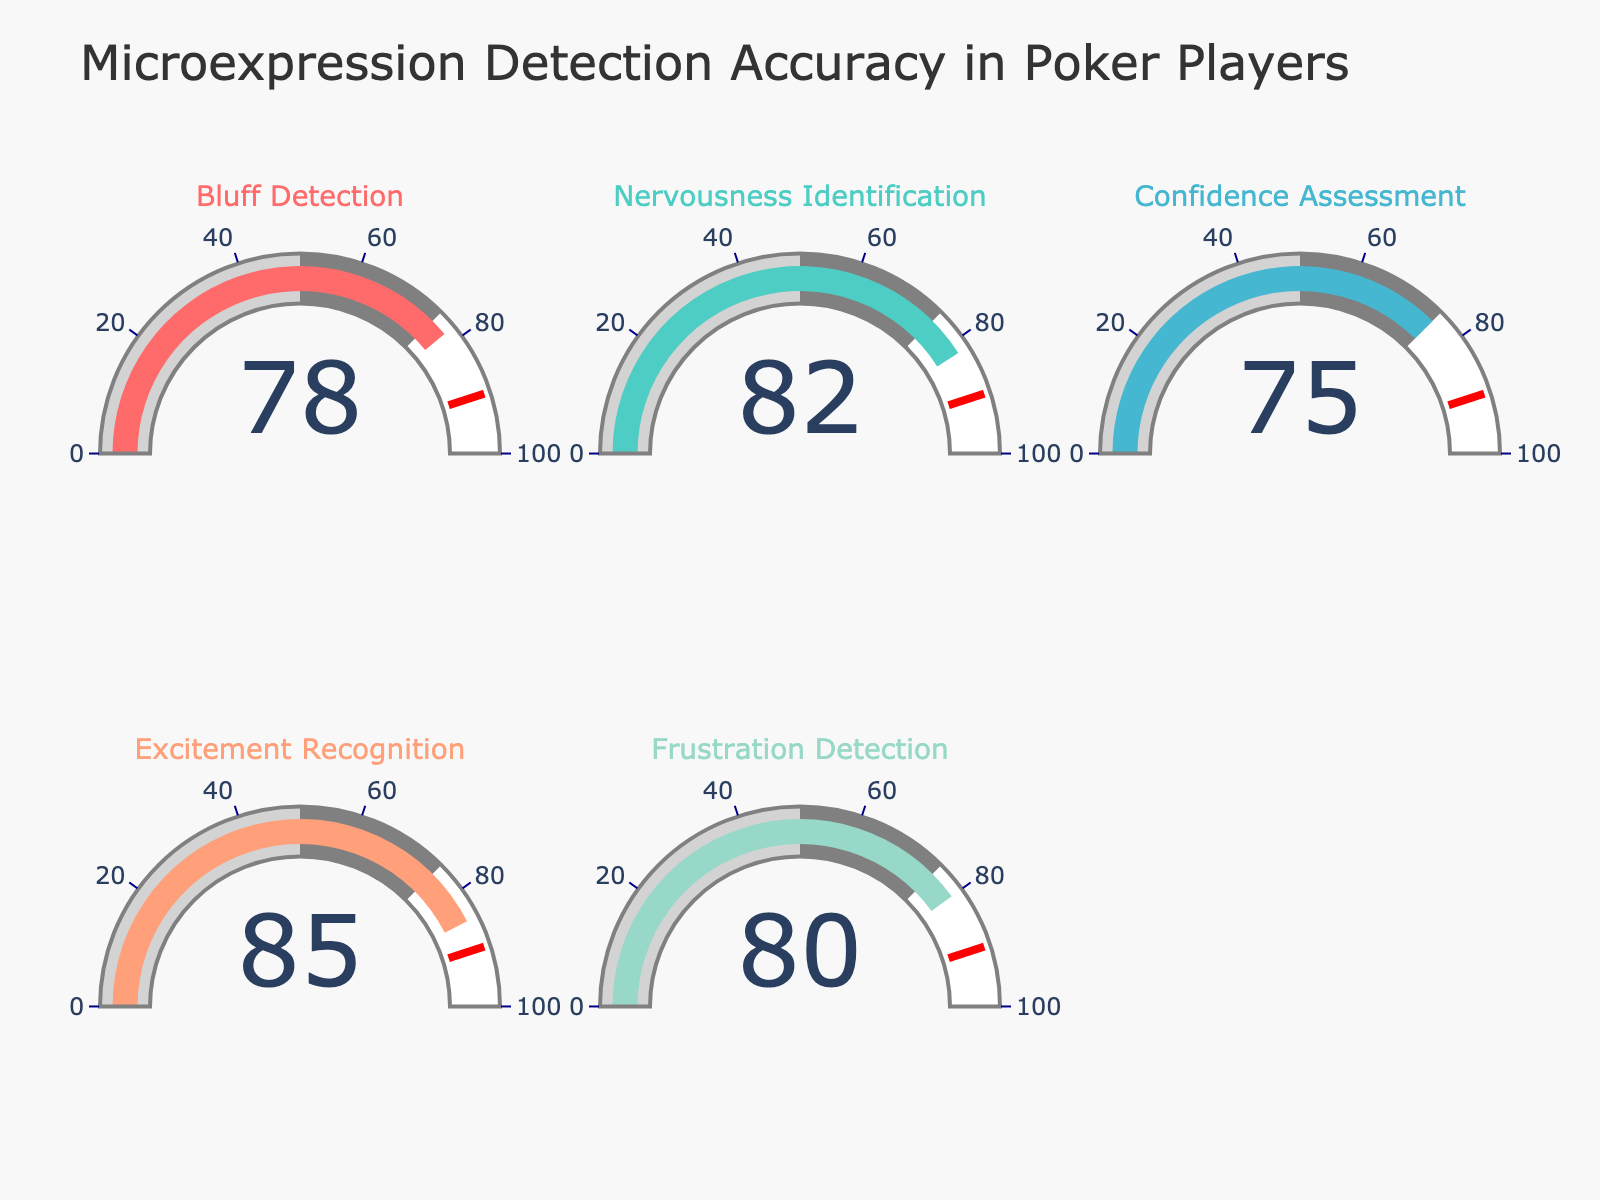What is the title of the figure? The title of the figure is displayed prominently at the top and reads "Microexpression Detection Accuracy in Poker Players".
Answer: Microexpression Detection Accuracy in Poker Players Which skill has the highest accuracy rate? The gauge chart visually shows the accuracy rates for various skills, and the highest value is displayed for "Excitement Recognition" at 85.
Answer: Excitement Recognition What is the range of numbers displayed on the gauges? Each gauge has an axis range that starts from 0 and ends at 100, as indicated by the tick marks on the gauge.
Answer: 0 to 100 What's the average accuracy rate across all skills? To find the average accuracy rate, sum all the individual accuracies and then divide by the number of skills. The sum is 78+82+75+85+80 = 400. There are 5 skills, so the average is 400/5 = 80.
Answer: 80 Which gauge color is used for "Nervousness Identification"? The gauge for "Nervousness Identification" has a light green color which helps distinguish it from the others.
Answer: Light green Is the accuracy rate for "Confidence Assessment" higher or lower than "Bluff Detection"? The gauge for "Confidence Assessment" shows an accuracy of 75, and the gauge for "Bluff Detection" shows 78, meaning the former is lower.
Answer: Lower What is the difference between the highest and lowest accuracy rates? The highest accuracy rate is 85 ("Excitement Recognition") and the lowest is 75 ("Confidence Assessment"). The difference is 85 - 75 = 10.
Answer: 10 What threshold value is indicated by the red line on the gauges? The red line on the gauges represents a threshold value, which is set at 90 indicated on the gauge.
Answer: 90 Which skills have an accuracy rate of 80 or above? By examining the gauges, the skills with an accuracy rate of 80 or above are "Nervousness Identification" (82), "Excitement Recognition" (85), and "Frustration Detection" (80).
Answer: Nervousness Identification, Excitement Recognition, Frustration Detection 